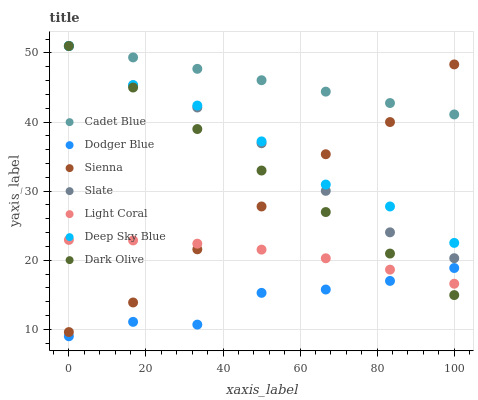Does Dodger Blue have the minimum area under the curve?
Answer yes or no. Yes. Does Cadet Blue have the maximum area under the curve?
Answer yes or no. Yes. Does Slate have the minimum area under the curve?
Answer yes or no. No. Does Slate have the maximum area under the curve?
Answer yes or no. No. Is Cadet Blue the smoothest?
Answer yes or no. Yes. Is Dodger Blue the roughest?
Answer yes or no. Yes. Is Slate the smoothest?
Answer yes or no. No. Is Slate the roughest?
Answer yes or no. No. Does Dodger Blue have the lowest value?
Answer yes or no. Yes. Does Slate have the lowest value?
Answer yes or no. No. Does Deep Sky Blue have the highest value?
Answer yes or no. Yes. Does Sienna have the highest value?
Answer yes or no. No. Is Light Coral less than Deep Sky Blue?
Answer yes or no. Yes. Is Cadet Blue greater than Dodger Blue?
Answer yes or no. Yes. Does Dark Olive intersect Light Coral?
Answer yes or no. Yes. Is Dark Olive less than Light Coral?
Answer yes or no. No. Is Dark Olive greater than Light Coral?
Answer yes or no. No. Does Light Coral intersect Deep Sky Blue?
Answer yes or no. No. 